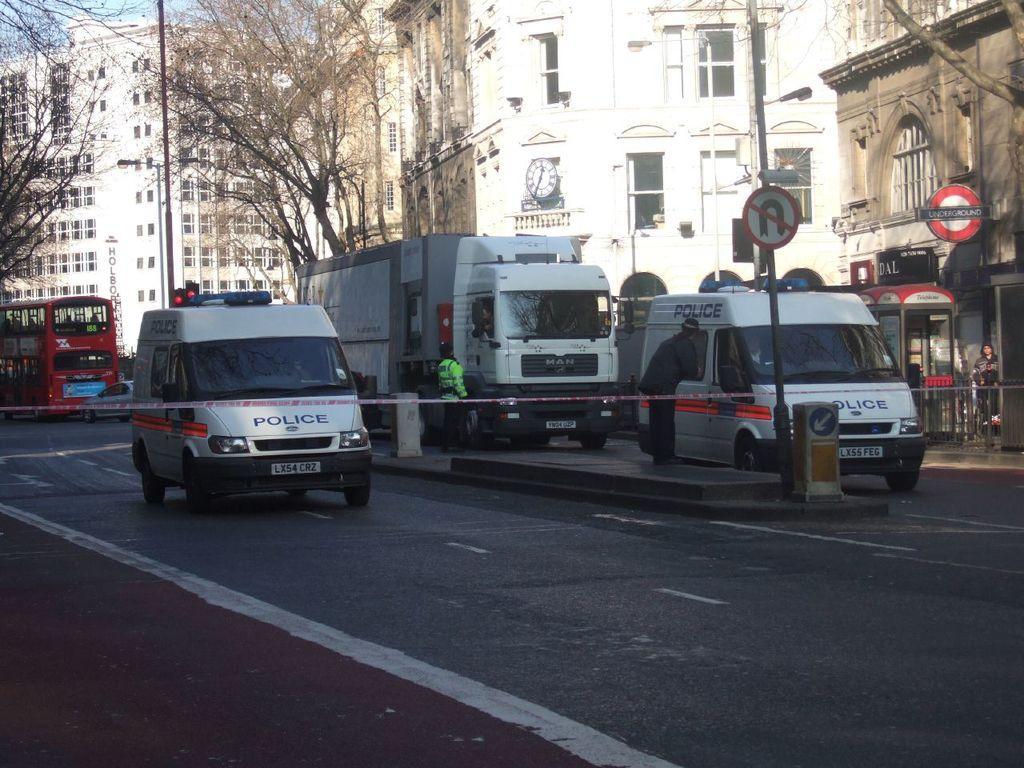Please provide a concise description of this image. In the image we can see a fencing. Behind the fencing there are some vehicles on the road. Behind the vehicles few people are standing and there are some poles and sign boards. Top of the image there are some trees and buildings. 